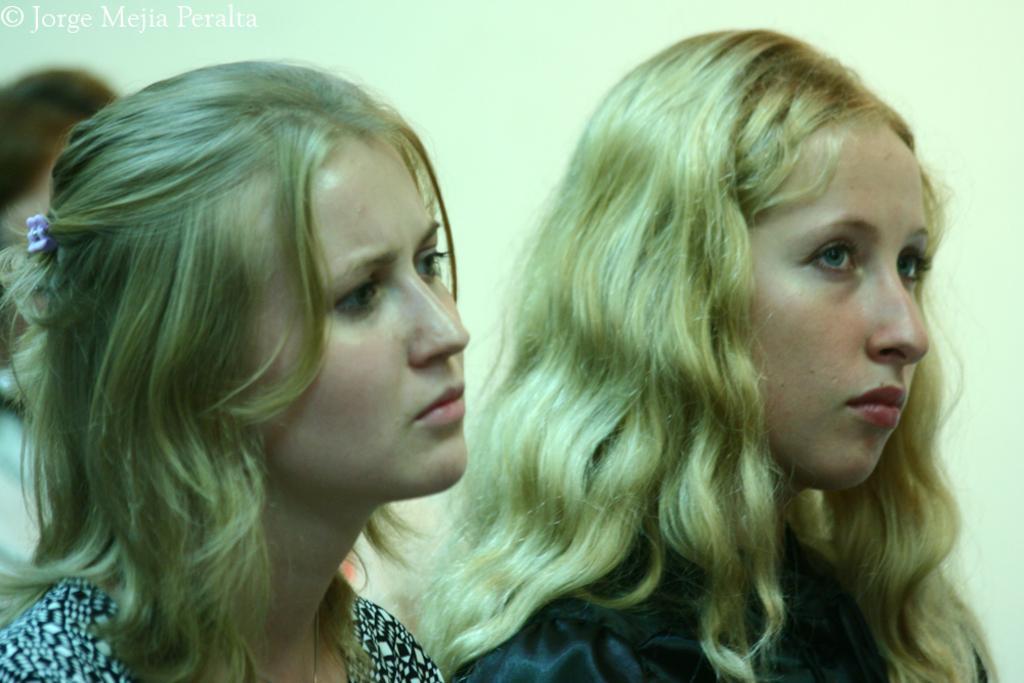Can you describe this image briefly? In this image I can see few people with different color dresses. In the back I can see the wall. I can also see the watermark in the image. 